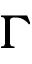<formula> <loc_0><loc_0><loc_500><loc_500>\Gamma</formula> 